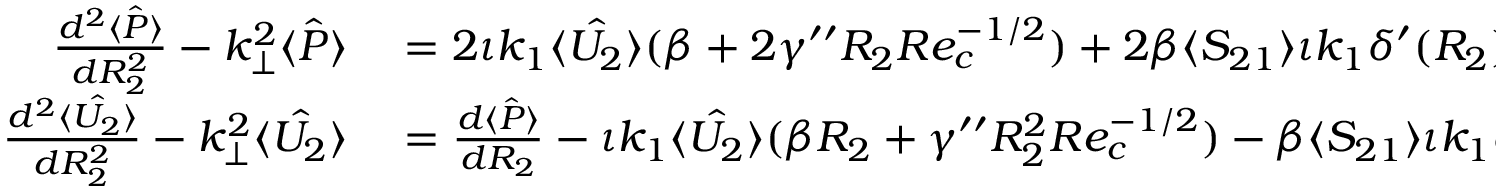<formula> <loc_0><loc_0><loc_500><loc_500>\begin{array} { r l } { \frac { d ^ { 2 } \hat { \langle P \rangle } } { d R _ { 2 } ^ { 2 } } - k _ { \perp } ^ { 2 } \hat { \langle P \rangle } } & = 2 \iota k _ { 1 } \hat { \langle U _ { 2 } \rangle } ( \beta + 2 \gamma ^ { \prime \prime } R _ { 2 } R e _ { c } ^ { - 1 / 2 } ) + 2 \beta \langle S _ { 2 1 } \rangle \iota k _ { 1 } \delta ^ { \prime } ( R _ { 2 } ) , } \\ { \frac { d ^ { 2 } \hat { \langle U _ { 2 } \rangle } } { d R _ { 2 } ^ { 2 } } - k _ { \perp } ^ { 2 } \hat { \langle U _ { 2 } \rangle } } & = \frac { d \hat { \langle P \rangle } } { d R _ { 2 } } - \iota k _ { 1 } \hat { \langle U _ { 2 } \rangle } ( \beta R _ { 2 } + \gamma ^ { \prime \prime } R _ { 2 } ^ { 2 } R e _ { c } ^ { - 1 / 2 } ) - \beta \langle S _ { 2 1 } \rangle \iota k _ { 1 } \delta ( R _ { 2 } ) , } \end{array}</formula> 